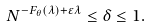<formula> <loc_0><loc_0><loc_500><loc_500>N ^ { - F _ { \theta } ( \lambda ) + \varepsilon \lambda } \leq \delta \leq 1 .</formula> 